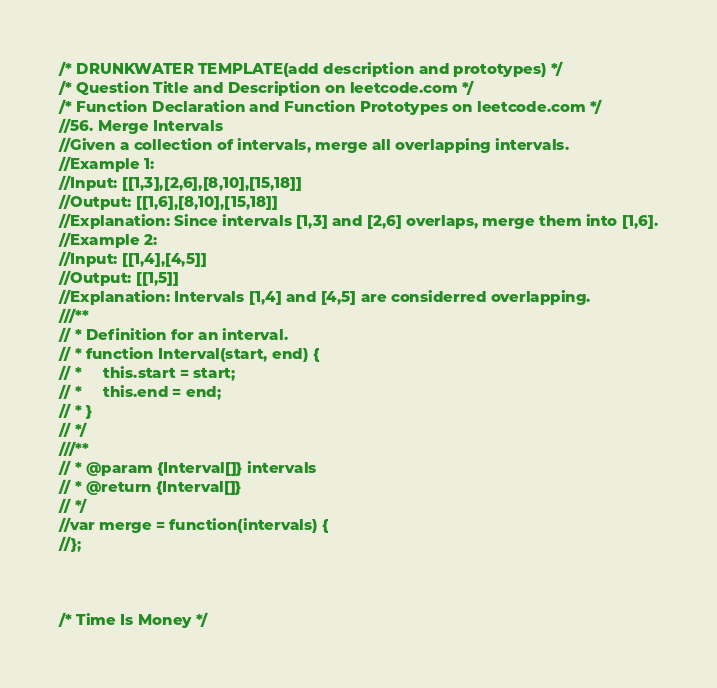Convert code to text. <code><loc_0><loc_0><loc_500><loc_500><_JavaScript_>/* DRUNKWATER TEMPLATE(add description and prototypes) */
/* Question Title and Description on leetcode.com */
/* Function Declaration and Function Prototypes on leetcode.com */
//56. Merge Intervals
//Given a collection of intervals, merge all overlapping intervals.
//Example 1:
//Input: [[1,3],[2,6],[8,10],[15,18]]
//Output: [[1,6],[8,10],[15,18]]
//Explanation: Since intervals [1,3] and [2,6] overlaps, merge them into [1,6].
//Example 2:
//Input: [[1,4],[4,5]]
//Output: [[1,5]]
//Explanation: Intervals [1,4] and [4,5] are considerred overlapping.
///**
// * Definition for an interval.
// * function Interval(start, end) {
// *     this.start = start;
// *     this.end = end;
// * }
// */
///**
// * @param {Interval[]} intervals
// * @return {Interval[]}
// */
//var merge = function(intervals) {
//};



/* Time Is Money */</code> 